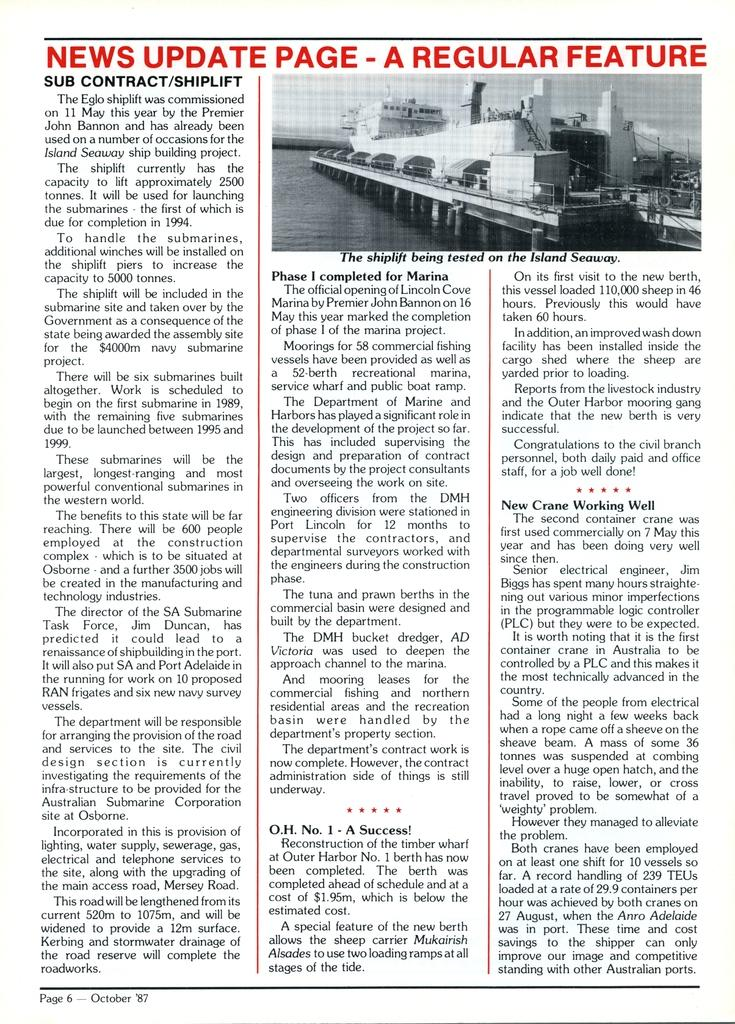Provide a one-sentence caption for the provided image. A news update page for a shiplift being tested on the Island Seaway. 